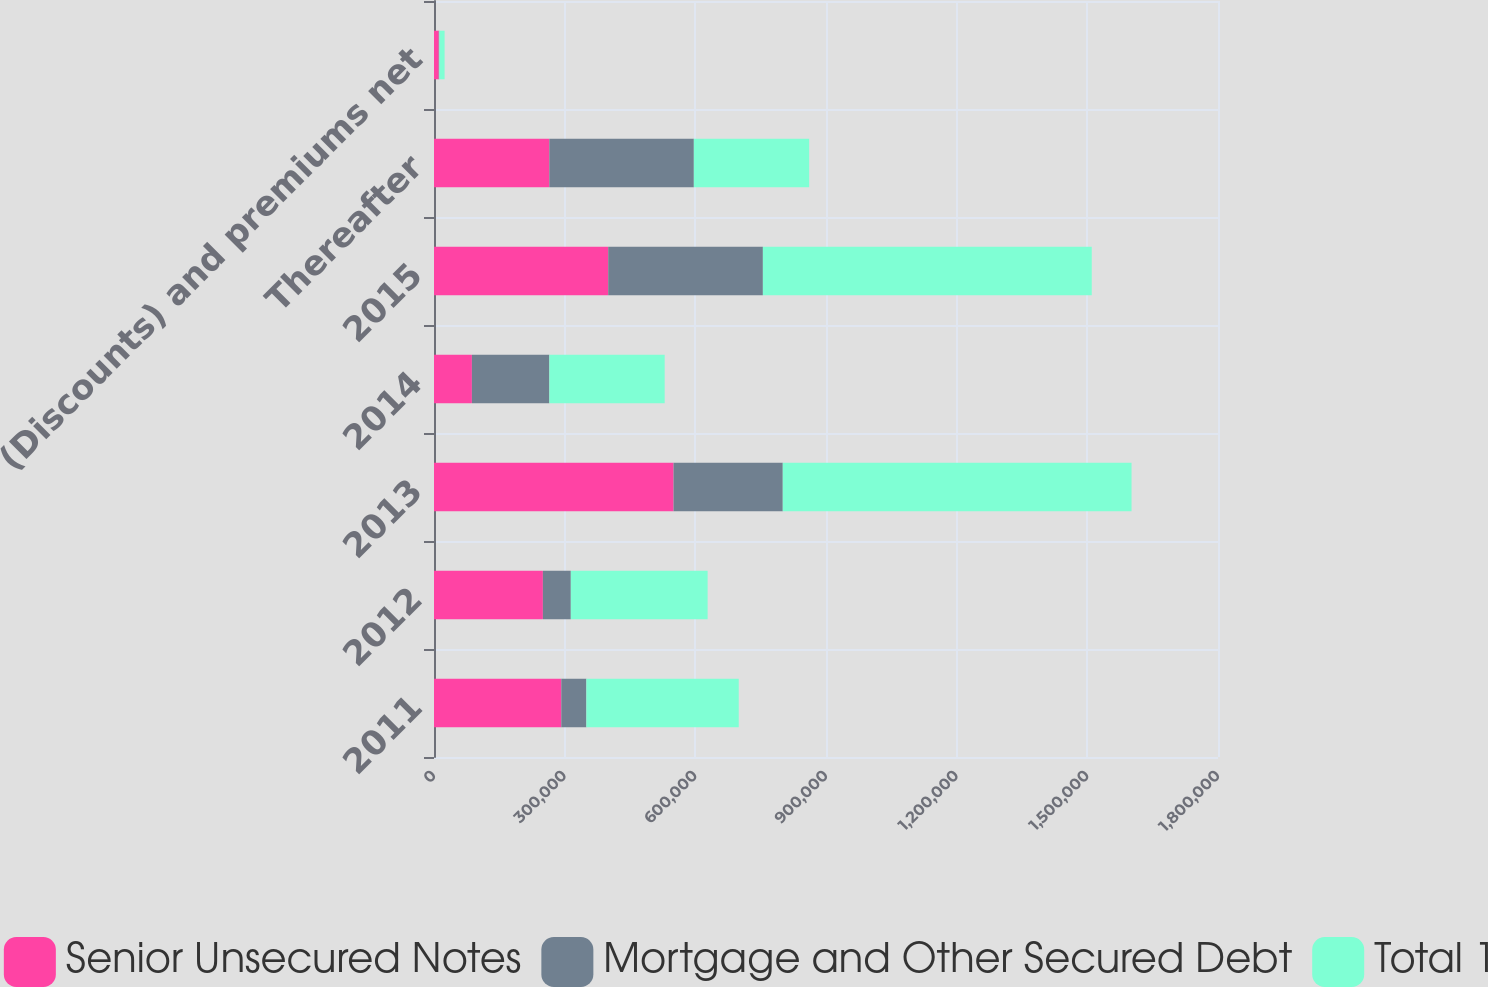<chart> <loc_0><loc_0><loc_500><loc_500><stacked_bar_chart><ecel><fcel>2011<fcel>2012<fcel>2013<fcel>2014<fcel>2015<fcel>Thereafter<fcel>(Discounts) and premiums net<nl><fcel>Senior Unsecured Notes<fcel>292265<fcel>250000<fcel>550000<fcel>87000<fcel>400000<fcel>264809<fcel>10886<nl><fcel>Mortgage and Other Secured Debt<fcel>57571<fcel>64103<fcel>250741<fcel>177809<fcel>355080<fcel>331748<fcel>1273<nl><fcel>Total 1<fcel>349836<fcel>314103<fcel>800741<fcel>264809<fcel>755080<fcel>264809<fcel>12159<nl></chart> 